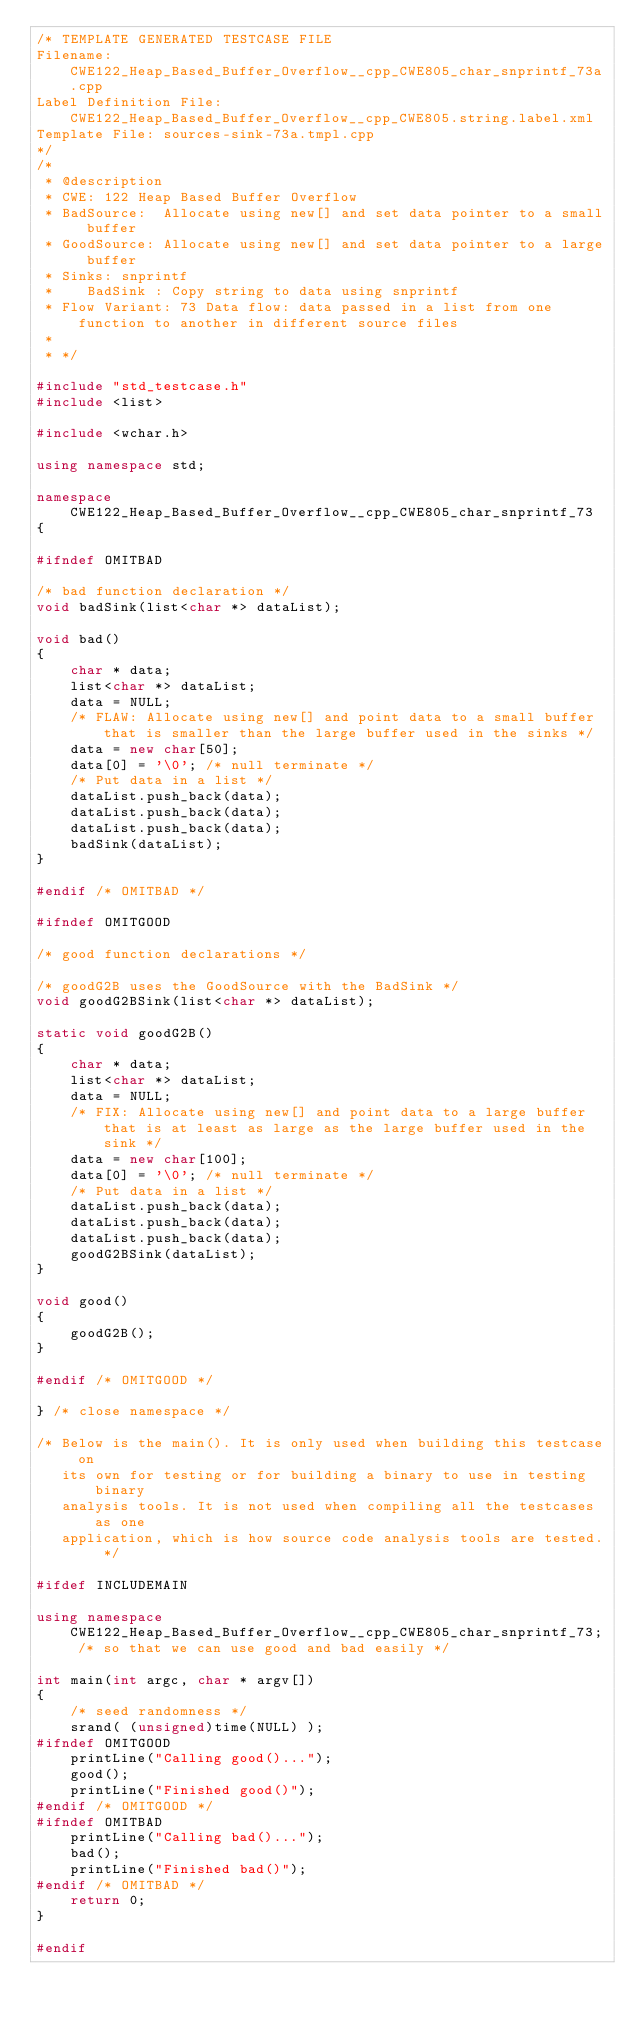<code> <loc_0><loc_0><loc_500><loc_500><_C++_>/* TEMPLATE GENERATED TESTCASE FILE
Filename: CWE122_Heap_Based_Buffer_Overflow__cpp_CWE805_char_snprintf_73a.cpp
Label Definition File: CWE122_Heap_Based_Buffer_Overflow__cpp_CWE805.string.label.xml
Template File: sources-sink-73a.tmpl.cpp
*/
/*
 * @description
 * CWE: 122 Heap Based Buffer Overflow
 * BadSource:  Allocate using new[] and set data pointer to a small buffer
 * GoodSource: Allocate using new[] and set data pointer to a large buffer
 * Sinks: snprintf
 *    BadSink : Copy string to data using snprintf
 * Flow Variant: 73 Data flow: data passed in a list from one function to another in different source files
 *
 * */

#include "std_testcase.h"
#include <list>

#include <wchar.h>

using namespace std;

namespace CWE122_Heap_Based_Buffer_Overflow__cpp_CWE805_char_snprintf_73
{

#ifndef OMITBAD

/* bad function declaration */
void badSink(list<char *> dataList);

void bad()
{
    char * data;
    list<char *> dataList;
    data = NULL;
    /* FLAW: Allocate using new[] and point data to a small buffer that is smaller than the large buffer used in the sinks */
    data = new char[50];
    data[0] = '\0'; /* null terminate */
    /* Put data in a list */
    dataList.push_back(data);
    dataList.push_back(data);
    dataList.push_back(data);
    badSink(dataList);
}

#endif /* OMITBAD */

#ifndef OMITGOOD

/* good function declarations */

/* goodG2B uses the GoodSource with the BadSink */
void goodG2BSink(list<char *> dataList);

static void goodG2B()
{
    char * data;
    list<char *> dataList;
    data = NULL;
    /* FIX: Allocate using new[] and point data to a large buffer that is at least as large as the large buffer used in the sink */
    data = new char[100];
    data[0] = '\0'; /* null terminate */
    /* Put data in a list */
    dataList.push_back(data);
    dataList.push_back(data);
    dataList.push_back(data);
    goodG2BSink(dataList);
}

void good()
{
    goodG2B();
}

#endif /* OMITGOOD */

} /* close namespace */

/* Below is the main(). It is only used when building this testcase on
   its own for testing or for building a binary to use in testing binary
   analysis tools. It is not used when compiling all the testcases as one
   application, which is how source code analysis tools are tested. */

#ifdef INCLUDEMAIN

using namespace CWE122_Heap_Based_Buffer_Overflow__cpp_CWE805_char_snprintf_73; /* so that we can use good and bad easily */

int main(int argc, char * argv[])
{
    /* seed randomness */
    srand( (unsigned)time(NULL) );
#ifndef OMITGOOD
    printLine("Calling good()...");
    good();
    printLine("Finished good()");
#endif /* OMITGOOD */
#ifndef OMITBAD
    printLine("Calling bad()...");
    bad();
    printLine("Finished bad()");
#endif /* OMITBAD */
    return 0;
}

#endif
</code> 